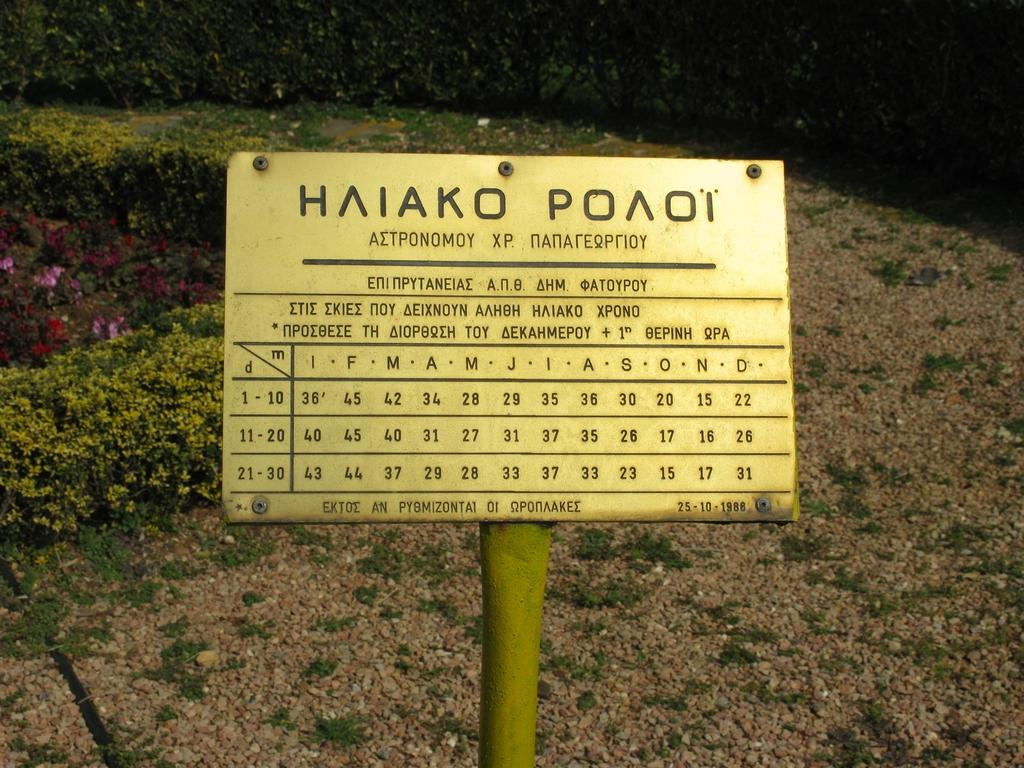What is the main object in the middle of the image? There is a board with text in the middle of the image. What type of vegetation can be seen in the image? There are plants and flowers in the image. What type of jam is being advertised on the watch in the image? There is no watch or jam present in the image; it features a board with text and plants with flowers. 